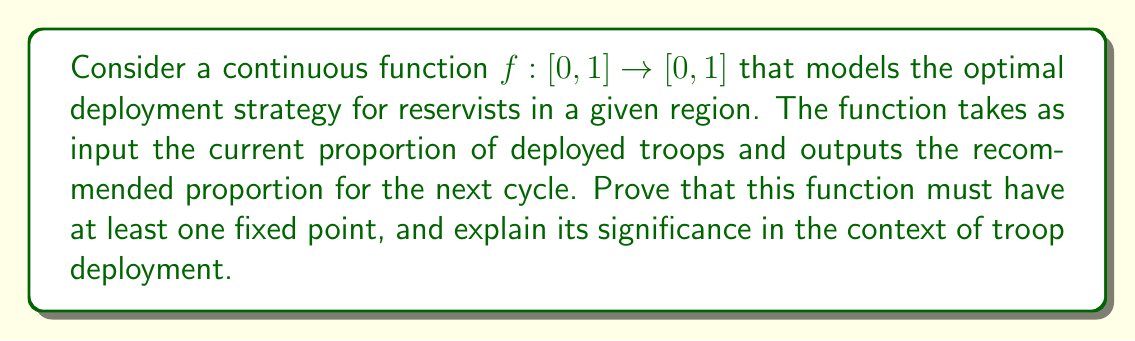What is the answer to this math problem? To prove that the function $f: [0, 1] \rightarrow [0, 1]$ has at least one fixed point, we can use the Brouwer Fixed-Point Theorem. The proof follows these steps:

1) First, we need to verify that the conditions for the Brouwer Fixed-Point Theorem are met:
   a) The domain $[0, 1]$ is a closed, bounded, and convex set in $\mathbb{R}$.
   b) The function $f$ is continuous on $[0, 1]$.
   c) The function $f$ maps $[0, 1]$ to itself.

2) Since all these conditions are satisfied, we can apply the Brouwer Fixed-Point Theorem, which states that any continuous function from a convex compact subset of a Euclidean space to itself has a fixed point.

3) Therefore, there exists at least one point $x_0 \in [0, 1]$ such that $f(x_0) = x_0$.

The significance of this fixed point in the context of troop deployment:

1) The fixed point $x_0$ represents a stable deployment strategy, where the recommended proportion of troops to deploy remains constant from one cycle to the next.

2) This stable point could indicate an optimal balance between having enough troops deployed for effective operations and maintaining a sufficient reserve force.

3) For a reservist, understanding this fixed point helps in long-term planning and resource allocation, as it provides insight into the likely long-term deployment levels.

4) From a policy perspective, this fixed point could be used to set benchmarks or targets for troop deployment, helping to create more predictable and sustainable deployment cycles for reservists.

5) However, it's important to note that while the existence of a fixed point is guaranteed, its uniqueness is not. There could be multiple fixed points, each representing different stable deployment strategies under various conditions.
Answer: The function $f: [0, 1] \rightarrow [0, 1]$ has at least one fixed point $x_0 \in [0, 1]$ such that $f(x_0) = x_0$, representing a stable troop deployment strategy. 